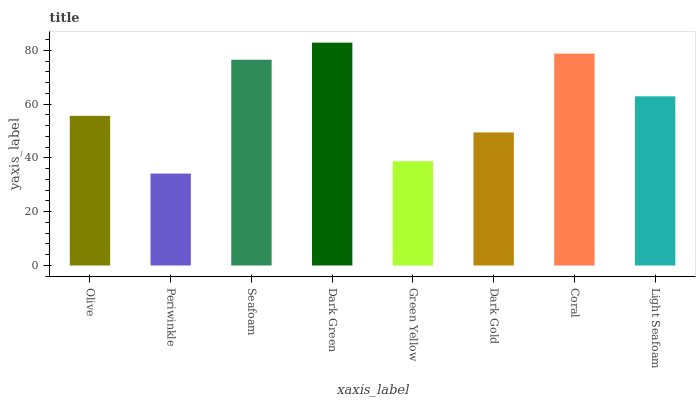Is Periwinkle the minimum?
Answer yes or no. Yes. Is Dark Green the maximum?
Answer yes or no. Yes. Is Seafoam the minimum?
Answer yes or no. No. Is Seafoam the maximum?
Answer yes or no. No. Is Seafoam greater than Periwinkle?
Answer yes or no. Yes. Is Periwinkle less than Seafoam?
Answer yes or no. Yes. Is Periwinkle greater than Seafoam?
Answer yes or no. No. Is Seafoam less than Periwinkle?
Answer yes or no. No. Is Light Seafoam the high median?
Answer yes or no. Yes. Is Olive the low median?
Answer yes or no. Yes. Is Olive the high median?
Answer yes or no. No. Is Light Seafoam the low median?
Answer yes or no. No. 